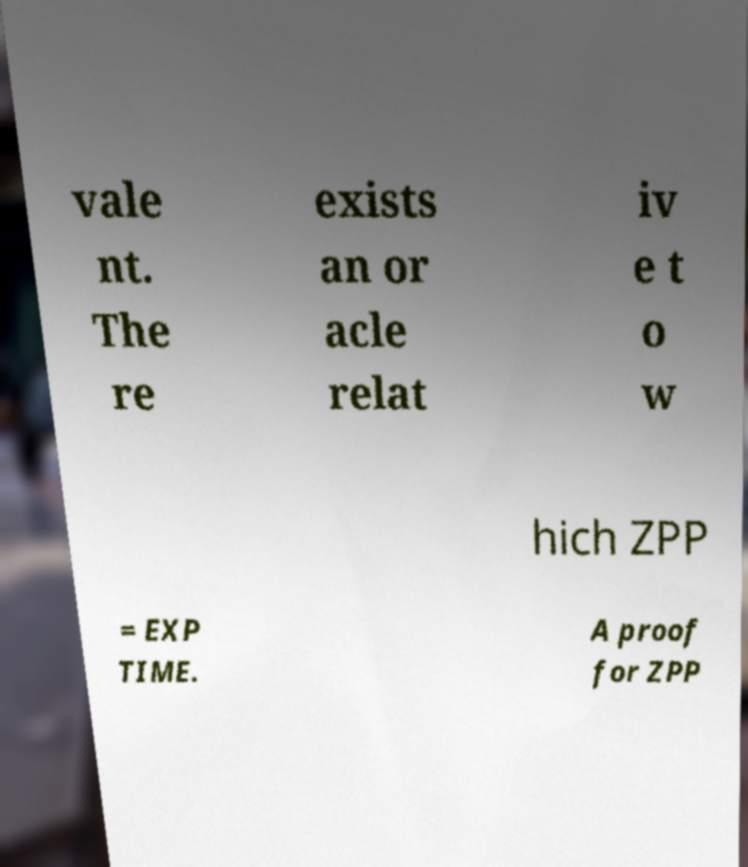There's text embedded in this image that I need extracted. Can you transcribe it verbatim? vale nt. The re exists an or acle relat iv e t o w hich ZPP = EXP TIME. A proof for ZPP 